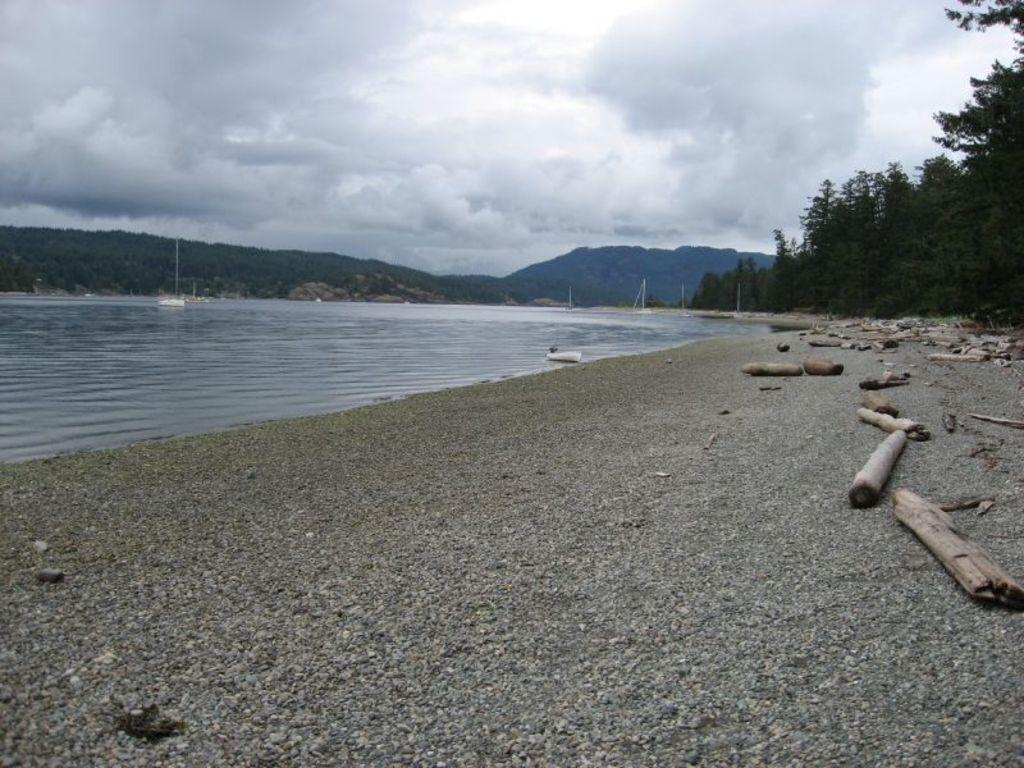What objects are placed on the stones in the image? There are sticks on the stones in the image. What can be seen near the ground in the image? There is water visible near the ground in the image. What type of natural features are visible in the background of the image? There are trees, mountains, and clouds in the background of the image. What part of the sky is visible in the background of the image? The sky is visible in the background of the image. What type of property is visible in the image? There is no property visible in the image; it features natural elements such as stones, water, trees, mountains, clouds, and the sky. Can you see any smoke coming from the mountains in the image? There is no smoke visible in the image; it only shows natural elements and no signs of human activity or pollution. 